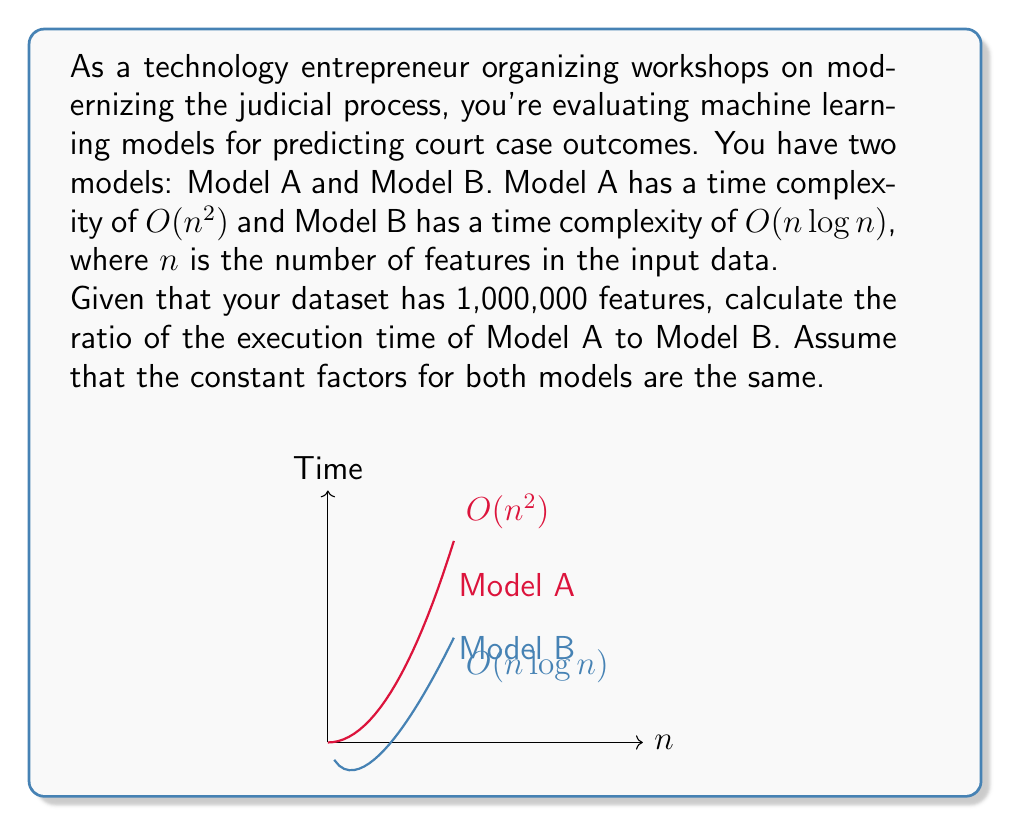Help me with this question. Let's approach this step-by-step:

1) We're comparing the time complexities $O(n^2)$ and $O(n \log n)$ for $n = 1,000,000$.

2) For Model A: $T_A = k_1 \cdot n^2$, where $k_1$ is some constant.
   For Model B: $T_B = k_2 \cdot n \log n$, where $k_2$ is some constant.

3) We're told to assume the constant factors are the same, so $k_1 = k_2 = k$.

4) Now, let's calculate the ratio:

   $$\frac{T_A}{T_B} = \frac{k \cdot n^2}{k \cdot n \log n} = \frac{n^2}{n \log n} = \frac{n}{\log n}$$

5) Substituting $n = 1,000,000$:

   $$\frac{T_A}{T_B} = \frac{1,000,000}{\log 1,000,000}$$

6) $\log 1,000,000 \approx 19.93$ (using base-2 logarithm, as is common in computational complexity)

7) Therefore:

   $$\frac{T_A}{T_B} \approx \frac{1,000,000}{19.93} \approx 50,175.11$$

This means Model A will take approximately 50,175 times longer to execute than Model B for this input size.
Answer: $50,175$ 